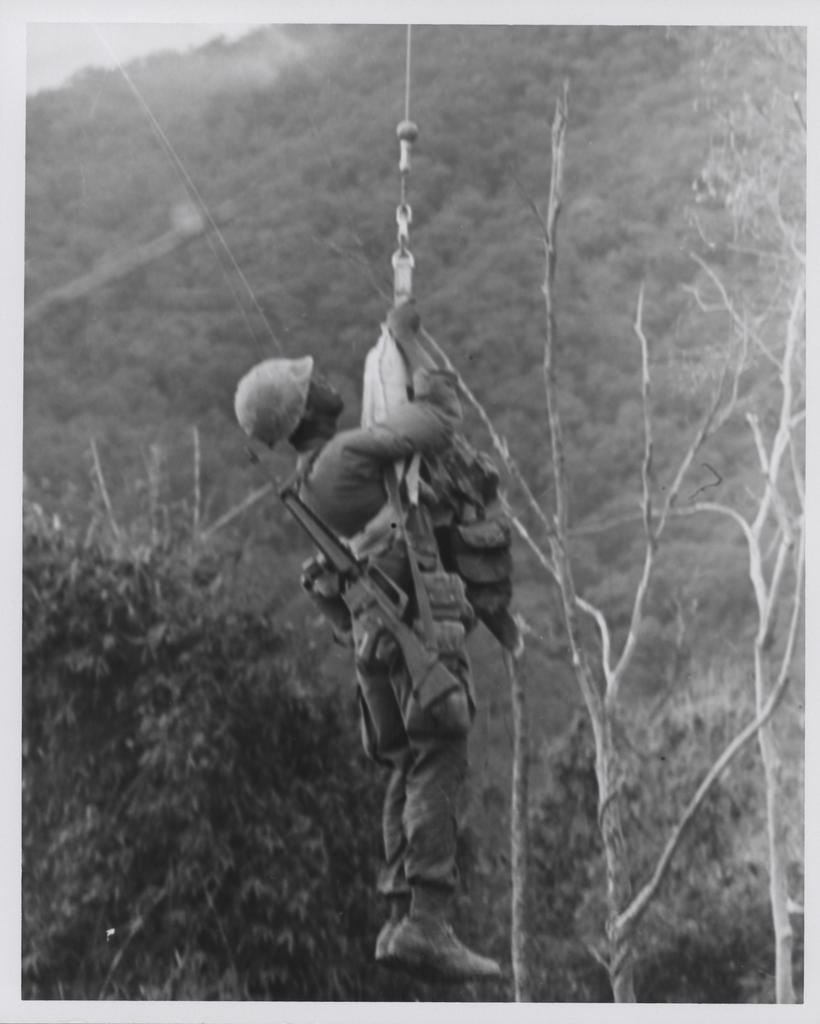What type of person is in the image? There is an army personnel in the image. What is the army personnel doing in the image? The army personnel is hanging from a rope. What natural features can be seen in the image? There are trees and mountains visible in the image. What type of throat lozenges can be seen in the image? There are no throat lozenges present in the image. What type of face cream is visible in the image? There is no face cream visible in the image. 